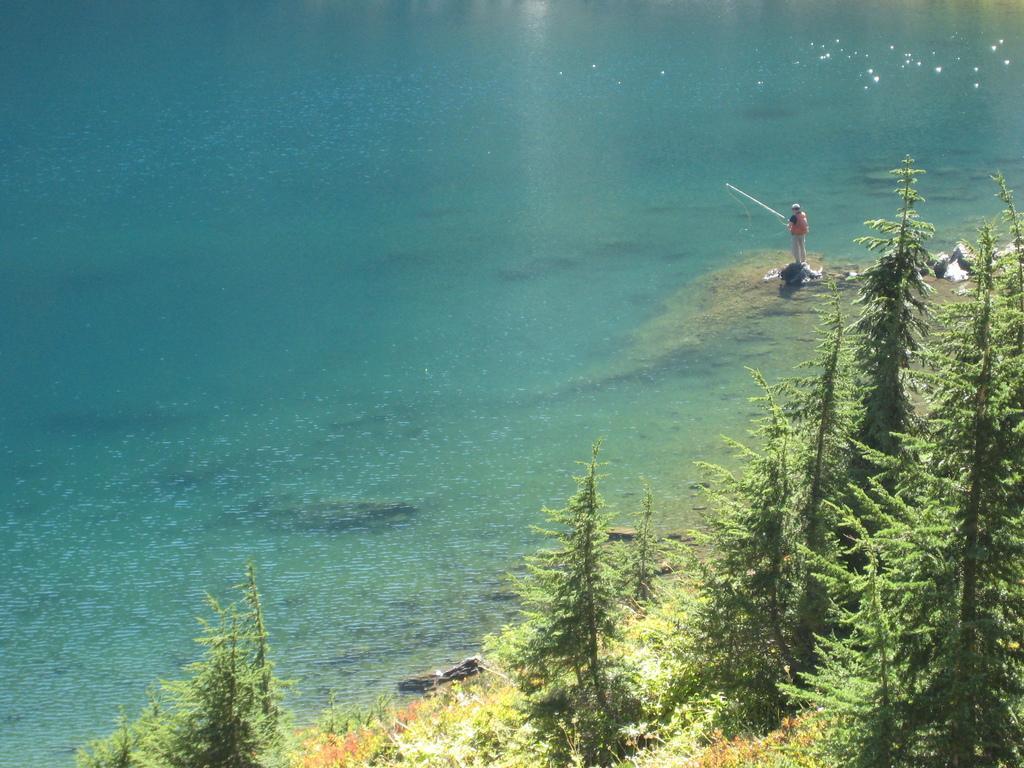Please provide a concise description of this image. In the foreground we can see the trees on the side of the ocean. Here we can see a man and he is holding the fishing device in his hands. Here we can see the water. 